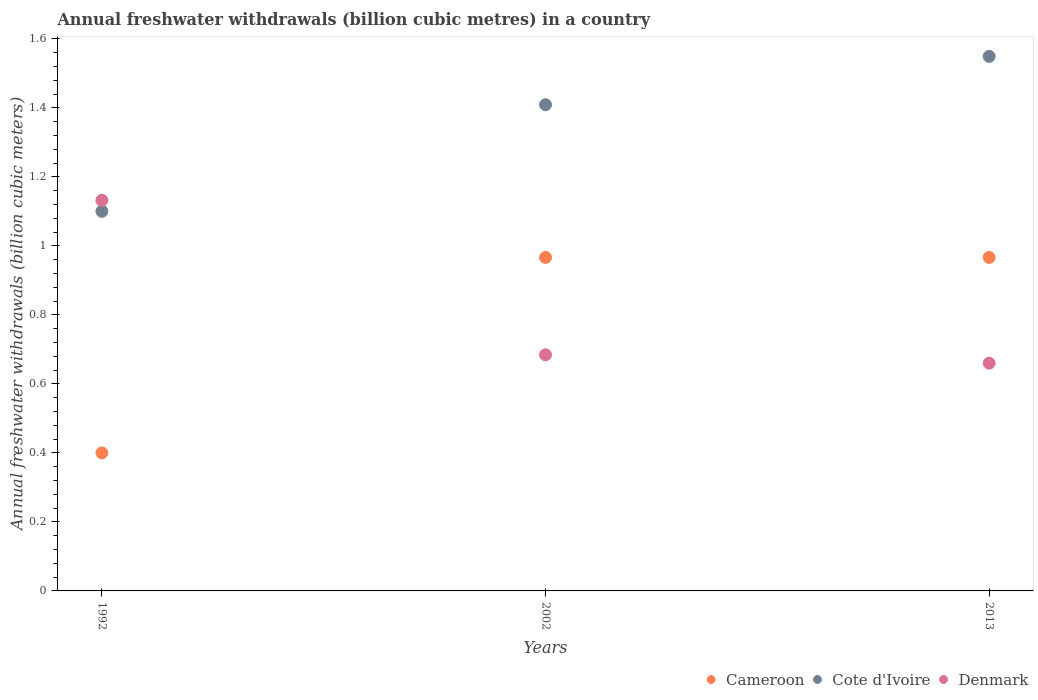How many different coloured dotlines are there?
Provide a short and direct response. 3. Across all years, what is the maximum annual freshwater withdrawals in Cameroon?
Keep it short and to the point. 0.97. Across all years, what is the minimum annual freshwater withdrawals in Denmark?
Provide a succinct answer. 0.66. In which year was the annual freshwater withdrawals in Cote d'Ivoire minimum?
Make the answer very short. 1992. What is the total annual freshwater withdrawals in Cameroon in the graph?
Your answer should be very brief. 2.33. What is the difference between the annual freshwater withdrawals in Cote d'Ivoire in 1992 and that in 2002?
Your response must be concise. -0.31. What is the difference between the annual freshwater withdrawals in Denmark in 1992 and the annual freshwater withdrawals in Cote d'Ivoire in 2013?
Your answer should be very brief. -0.42. What is the average annual freshwater withdrawals in Cameroon per year?
Ensure brevity in your answer.  0.78. In the year 2013, what is the difference between the annual freshwater withdrawals in Denmark and annual freshwater withdrawals in Cameroon?
Make the answer very short. -0.31. What is the ratio of the annual freshwater withdrawals in Denmark in 1992 to that in 2013?
Your response must be concise. 1.72. Is the difference between the annual freshwater withdrawals in Denmark in 2002 and 2013 greater than the difference between the annual freshwater withdrawals in Cameroon in 2002 and 2013?
Your answer should be compact. Yes. What is the difference between the highest and the second highest annual freshwater withdrawals in Cote d'Ivoire?
Provide a succinct answer. 0.14. What is the difference between the highest and the lowest annual freshwater withdrawals in Cameroon?
Your answer should be compact. 0.57. Is the sum of the annual freshwater withdrawals in Denmark in 1992 and 2002 greater than the maximum annual freshwater withdrawals in Cote d'Ivoire across all years?
Provide a short and direct response. Yes. Is it the case that in every year, the sum of the annual freshwater withdrawals in Cote d'Ivoire and annual freshwater withdrawals in Denmark  is greater than the annual freshwater withdrawals in Cameroon?
Your answer should be compact. Yes. Is the annual freshwater withdrawals in Cote d'Ivoire strictly greater than the annual freshwater withdrawals in Cameroon over the years?
Provide a succinct answer. Yes. Are the values on the major ticks of Y-axis written in scientific E-notation?
Your response must be concise. No. Does the graph contain grids?
Give a very brief answer. No. Where does the legend appear in the graph?
Offer a terse response. Bottom right. How are the legend labels stacked?
Your answer should be compact. Horizontal. What is the title of the graph?
Offer a terse response. Annual freshwater withdrawals (billion cubic metres) in a country. Does "Tuvalu" appear as one of the legend labels in the graph?
Make the answer very short. No. What is the label or title of the Y-axis?
Keep it short and to the point. Annual freshwater withdrawals (billion cubic meters). What is the Annual freshwater withdrawals (billion cubic meters) of Denmark in 1992?
Ensure brevity in your answer.  1.13. What is the Annual freshwater withdrawals (billion cubic meters) of Cameroon in 2002?
Provide a succinct answer. 0.97. What is the Annual freshwater withdrawals (billion cubic meters) of Cote d'Ivoire in 2002?
Your answer should be compact. 1.41. What is the Annual freshwater withdrawals (billion cubic meters) in Denmark in 2002?
Your answer should be very brief. 0.68. What is the Annual freshwater withdrawals (billion cubic meters) of Cameroon in 2013?
Provide a short and direct response. 0.97. What is the Annual freshwater withdrawals (billion cubic meters) of Cote d'Ivoire in 2013?
Your answer should be very brief. 1.55. What is the Annual freshwater withdrawals (billion cubic meters) in Denmark in 2013?
Ensure brevity in your answer.  0.66. Across all years, what is the maximum Annual freshwater withdrawals (billion cubic meters) in Cameroon?
Your answer should be compact. 0.97. Across all years, what is the maximum Annual freshwater withdrawals (billion cubic meters) of Cote d'Ivoire?
Offer a very short reply. 1.55. Across all years, what is the maximum Annual freshwater withdrawals (billion cubic meters) of Denmark?
Provide a succinct answer. 1.13. Across all years, what is the minimum Annual freshwater withdrawals (billion cubic meters) of Denmark?
Offer a terse response. 0.66. What is the total Annual freshwater withdrawals (billion cubic meters) of Cameroon in the graph?
Make the answer very short. 2.33. What is the total Annual freshwater withdrawals (billion cubic meters) of Cote d'Ivoire in the graph?
Your response must be concise. 4.06. What is the total Annual freshwater withdrawals (billion cubic meters) in Denmark in the graph?
Give a very brief answer. 2.48. What is the difference between the Annual freshwater withdrawals (billion cubic meters) of Cameroon in 1992 and that in 2002?
Offer a very short reply. -0.57. What is the difference between the Annual freshwater withdrawals (billion cubic meters) of Cote d'Ivoire in 1992 and that in 2002?
Provide a short and direct response. -0.31. What is the difference between the Annual freshwater withdrawals (billion cubic meters) in Denmark in 1992 and that in 2002?
Provide a short and direct response. 0.45. What is the difference between the Annual freshwater withdrawals (billion cubic meters) of Cameroon in 1992 and that in 2013?
Keep it short and to the point. -0.57. What is the difference between the Annual freshwater withdrawals (billion cubic meters) of Cote d'Ivoire in 1992 and that in 2013?
Your answer should be very brief. -0.45. What is the difference between the Annual freshwater withdrawals (billion cubic meters) in Denmark in 1992 and that in 2013?
Offer a terse response. 0.47. What is the difference between the Annual freshwater withdrawals (billion cubic meters) of Cameroon in 2002 and that in 2013?
Your answer should be compact. 0. What is the difference between the Annual freshwater withdrawals (billion cubic meters) in Cote d'Ivoire in 2002 and that in 2013?
Keep it short and to the point. -0.14. What is the difference between the Annual freshwater withdrawals (billion cubic meters) in Denmark in 2002 and that in 2013?
Offer a terse response. 0.02. What is the difference between the Annual freshwater withdrawals (billion cubic meters) of Cameroon in 1992 and the Annual freshwater withdrawals (billion cubic meters) of Cote d'Ivoire in 2002?
Give a very brief answer. -1.01. What is the difference between the Annual freshwater withdrawals (billion cubic meters) of Cameroon in 1992 and the Annual freshwater withdrawals (billion cubic meters) of Denmark in 2002?
Make the answer very short. -0.28. What is the difference between the Annual freshwater withdrawals (billion cubic meters) in Cote d'Ivoire in 1992 and the Annual freshwater withdrawals (billion cubic meters) in Denmark in 2002?
Your response must be concise. 0.42. What is the difference between the Annual freshwater withdrawals (billion cubic meters) of Cameroon in 1992 and the Annual freshwater withdrawals (billion cubic meters) of Cote d'Ivoire in 2013?
Your response must be concise. -1.15. What is the difference between the Annual freshwater withdrawals (billion cubic meters) in Cameroon in 1992 and the Annual freshwater withdrawals (billion cubic meters) in Denmark in 2013?
Give a very brief answer. -0.26. What is the difference between the Annual freshwater withdrawals (billion cubic meters) of Cote d'Ivoire in 1992 and the Annual freshwater withdrawals (billion cubic meters) of Denmark in 2013?
Ensure brevity in your answer.  0.44. What is the difference between the Annual freshwater withdrawals (billion cubic meters) of Cameroon in 2002 and the Annual freshwater withdrawals (billion cubic meters) of Cote d'Ivoire in 2013?
Offer a very short reply. -0.58. What is the difference between the Annual freshwater withdrawals (billion cubic meters) of Cameroon in 2002 and the Annual freshwater withdrawals (billion cubic meters) of Denmark in 2013?
Provide a succinct answer. 0.31. What is the difference between the Annual freshwater withdrawals (billion cubic meters) of Cote d'Ivoire in 2002 and the Annual freshwater withdrawals (billion cubic meters) of Denmark in 2013?
Keep it short and to the point. 0.75. What is the average Annual freshwater withdrawals (billion cubic meters) in Cameroon per year?
Your answer should be very brief. 0.78. What is the average Annual freshwater withdrawals (billion cubic meters) of Cote d'Ivoire per year?
Keep it short and to the point. 1.35. What is the average Annual freshwater withdrawals (billion cubic meters) of Denmark per year?
Give a very brief answer. 0.83. In the year 1992, what is the difference between the Annual freshwater withdrawals (billion cubic meters) of Cameroon and Annual freshwater withdrawals (billion cubic meters) of Denmark?
Offer a terse response. -0.73. In the year 1992, what is the difference between the Annual freshwater withdrawals (billion cubic meters) of Cote d'Ivoire and Annual freshwater withdrawals (billion cubic meters) of Denmark?
Offer a very short reply. -0.03. In the year 2002, what is the difference between the Annual freshwater withdrawals (billion cubic meters) of Cameroon and Annual freshwater withdrawals (billion cubic meters) of Cote d'Ivoire?
Your answer should be very brief. -0.44. In the year 2002, what is the difference between the Annual freshwater withdrawals (billion cubic meters) in Cameroon and Annual freshwater withdrawals (billion cubic meters) in Denmark?
Provide a succinct answer. 0.28. In the year 2002, what is the difference between the Annual freshwater withdrawals (billion cubic meters) of Cote d'Ivoire and Annual freshwater withdrawals (billion cubic meters) of Denmark?
Offer a very short reply. 0.72. In the year 2013, what is the difference between the Annual freshwater withdrawals (billion cubic meters) of Cameroon and Annual freshwater withdrawals (billion cubic meters) of Cote d'Ivoire?
Provide a short and direct response. -0.58. In the year 2013, what is the difference between the Annual freshwater withdrawals (billion cubic meters) of Cameroon and Annual freshwater withdrawals (billion cubic meters) of Denmark?
Provide a short and direct response. 0.31. In the year 2013, what is the difference between the Annual freshwater withdrawals (billion cubic meters) of Cote d'Ivoire and Annual freshwater withdrawals (billion cubic meters) of Denmark?
Provide a succinct answer. 0.89. What is the ratio of the Annual freshwater withdrawals (billion cubic meters) of Cameroon in 1992 to that in 2002?
Give a very brief answer. 0.41. What is the ratio of the Annual freshwater withdrawals (billion cubic meters) in Cote d'Ivoire in 1992 to that in 2002?
Make the answer very short. 0.78. What is the ratio of the Annual freshwater withdrawals (billion cubic meters) in Denmark in 1992 to that in 2002?
Offer a terse response. 1.65. What is the ratio of the Annual freshwater withdrawals (billion cubic meters) in Cameroon in 1992 to that in 2013?
Provide a succinct answer. 0.41. What is the ratio of the Annual freshwater withdrawals (billion cubic meters) in Cote d'Ivoire in 1992 to that in 2013?
Keep it short and to the point. 0.71. What is the ratio of the Annual freshwater withdrawals (billion cubic meters) in Denmark in 1992 to that in 2013?
Ensure brevity in your answer.  1.72. What is the ratio of the Annual freshwater withdrawals (billion cubic meters) in Cameroon in 2002 to that in 2013?
Offer a terse response. 1. What is the ratio of the Annual freshwater withdrawals (billion cubic meters) in Cote d'Ivoire in 2002 to that in 2013?
Keep it short and to the point. 0.91. What is the ratio of the Annual freshwater withdrawals (billion cubic meters) of Denmark in 2002 to that in 2013?
Your response must be concise. 1.04. What is the difference between the highest and the second highest Annual freshwater withdrawals (billion cubic meters) of Cameroon?
Keep it short and to the point. 0. What is the difference between the highest and the second highest Annual freshwater withdrawals (billion cubic meters) in Cote d'Ivoire?
Provide a succinct answer. 0.14. What is the difference between the highest and the second highest Annual freshwater withdrawals (billion cubic meters) in Denmark?
Your response must be concise. 0.45. What is the difference between the highest and the lowest Annual freshwater withdrawals (billion cubic meters) of Cameroon?
Provide a short and direct response. 0.57. What is the difference between the highest and the lowest Annual freshwater withdrawals (billion cubic meters) in Cote d'Ivoire?
Give a very brief answer. 0.45. What is the difference between the highest and the lowest Annual freshwater withdrawals (billion cubic meters) in Denmark?
Offer a very short reply. 0.47. 